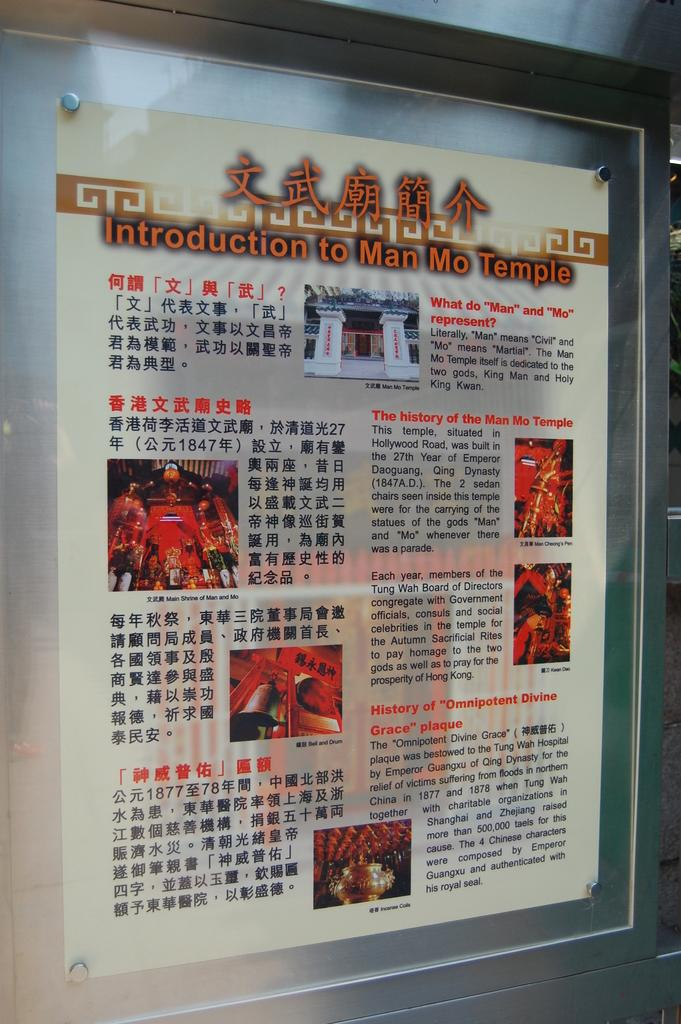<image>
Offer a succinct explanation of the picture presented. a poster on a wall that says 'introduction to man mo temple' 